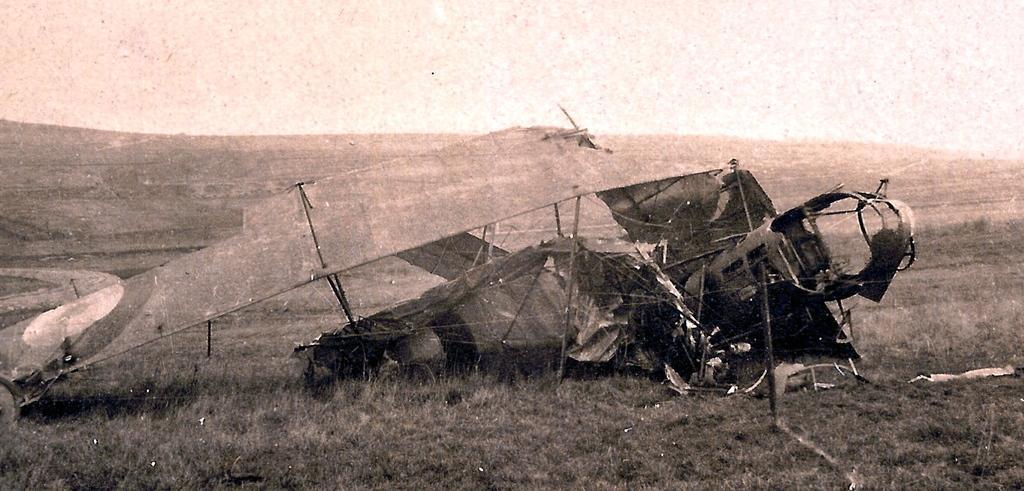Please provide a concise description of this image. This is an edited image. In the center of the image we can see the collapse airplane. In the background of the image we can see the ground and grass. At the top of the image we can see the sky. 